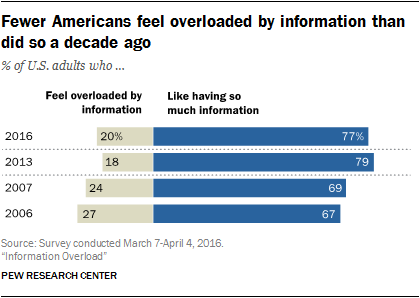Draw attention to some important aspects in this diagram. The multiplication of the largest gray bar by 2 does not result in a value greater than the smallest blue bar. In 2016, only 0.2% of U.S. adults reported feeling overloaded by the amount of information they receive. 